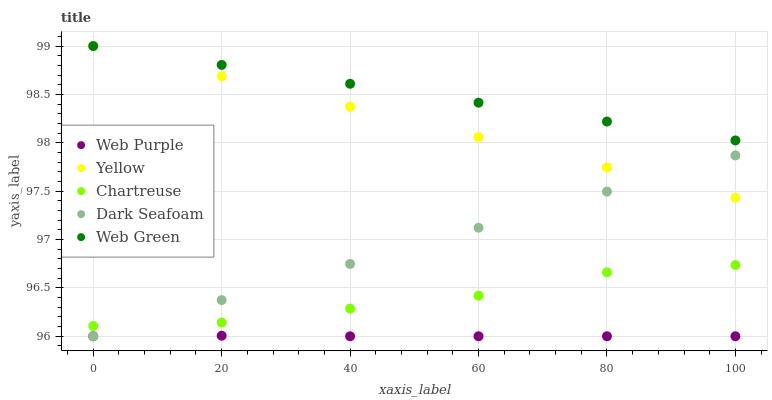Does Web Purple have the minimum area under the curve?
Answer yes or no. Yes. Does Web Green have the maximum area under the curve?
Answer yes or no. Yes. Does Web Green have the minimum area under the curve?
Answer yes or no. No. Does Web Purple have the maximum area under the curve?
Answer yes or no. No. Is Dark Seafoam the smoothest?
Answer yes or no. Yes. Is Chartreuse the roughest?
Answer yes or no. Yes. Is Web Purple the smoothest?
Answer yes or no. No. Is Web Purple the roughest?
Answer yes or no. No. Does Dark Seafoam have the lowest value?
Answer yes or no. Yes. Does Web Green have the lowest value?
Answer yes or no. No. Does Yellow have the highest value?
Answer yes or no. Yes. Does Web Purple have the highest value?
Answer yes or no. No. Is Web Purple less than Chartreuse?
Answer yes or no. Yes. Is Web Green greater than Chartreuse?
Answer yes or no. Yes. Does Dark Seafoam intersect Web Purple?
Answer yes or no. Yes. Is Dark Seafoam less than Web Purple?
Answer yes or no. No. Is Dark Seafoam greater than Web Purple?
Answer yes or no. No. Does Web Purple intersect Chartreuse?
Answer yes or no. No. 